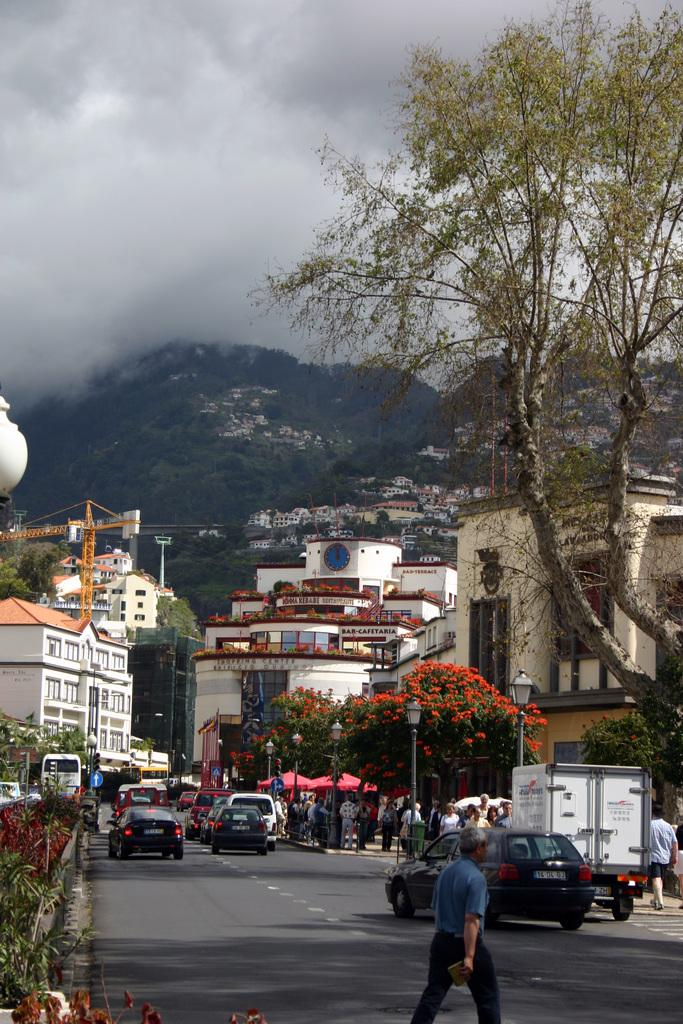What are the people in the image doing? The people in the image are walking in the city. What else can be seen on the streets in the image? There are vehicles on the road in the image. What type of structures are present in the city? There are buildings in the city. Can you describe the natural elements in the city? Trees and plants are visible in the city. What is used to illuminate the city at night? There are lights in the city. How are signs displayed in the city? Sign boards are attached to poles in the city. What geographical features can be seen in the city? There are hills in the city. What part of the environment is visible above the city? The sky is visible in the city. Where is the powder stored in the image? There is no mention of powder in the image, so it cannot be determined where it might be stored. What question is being asked on the sign board in the image? There is no indication of a question on any sign board in the image. What note is being played by the trees in the image? There is no mention of music or notes being played by trees in the image. 